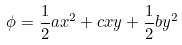Convert formula to latex. <formula><loc_0><loc_0><loc_500><loc_500>\phi = \frac { 1 } { 2 } a x ^ { 2 } + c x y + \frac { 1 } { 2 } b y ^ { 2 } \,</formula> 